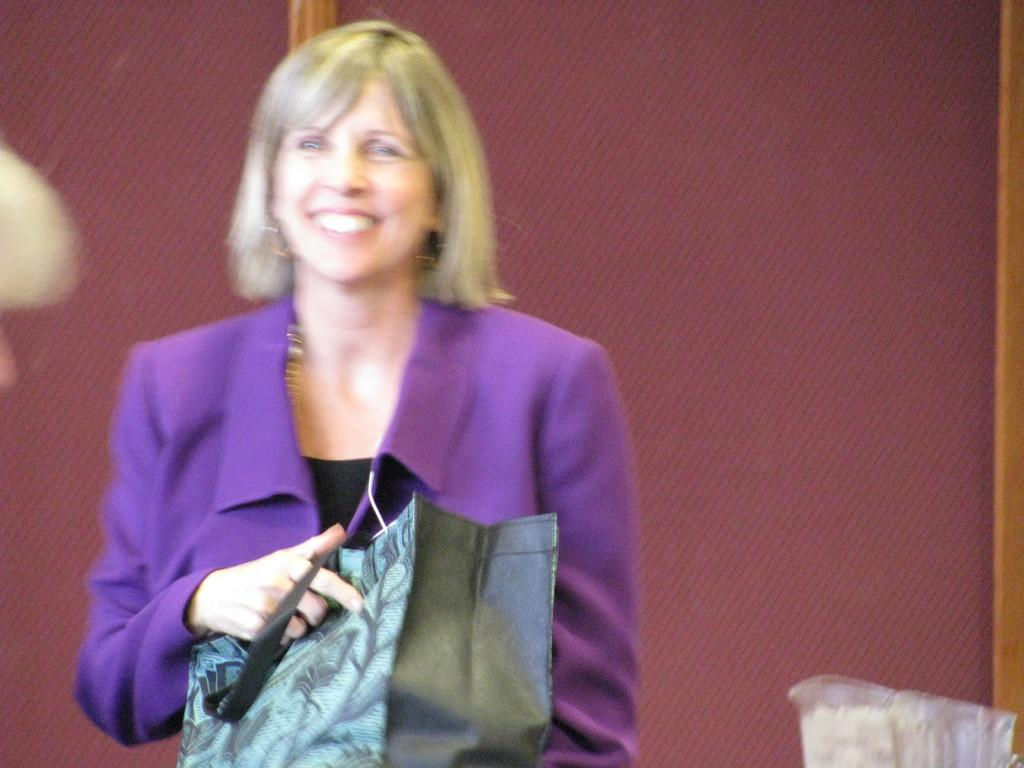Who is the main subject in the image? There is a woman in the image. What is the woman wearing? The woman is wearing a violet jacket. What is the woman holding in the image? The woman is holding a bag. What is the woman's facial expression? The woman is smiling. What can be seen on the right side of the image? There is an object on the right side of the image. What is a notable feature of the background in the image? There is a red window in the background of the image. What type of floor can be seen in the image? There is no information about the floor in the image, as the focus is on the woman and the objects around her. 